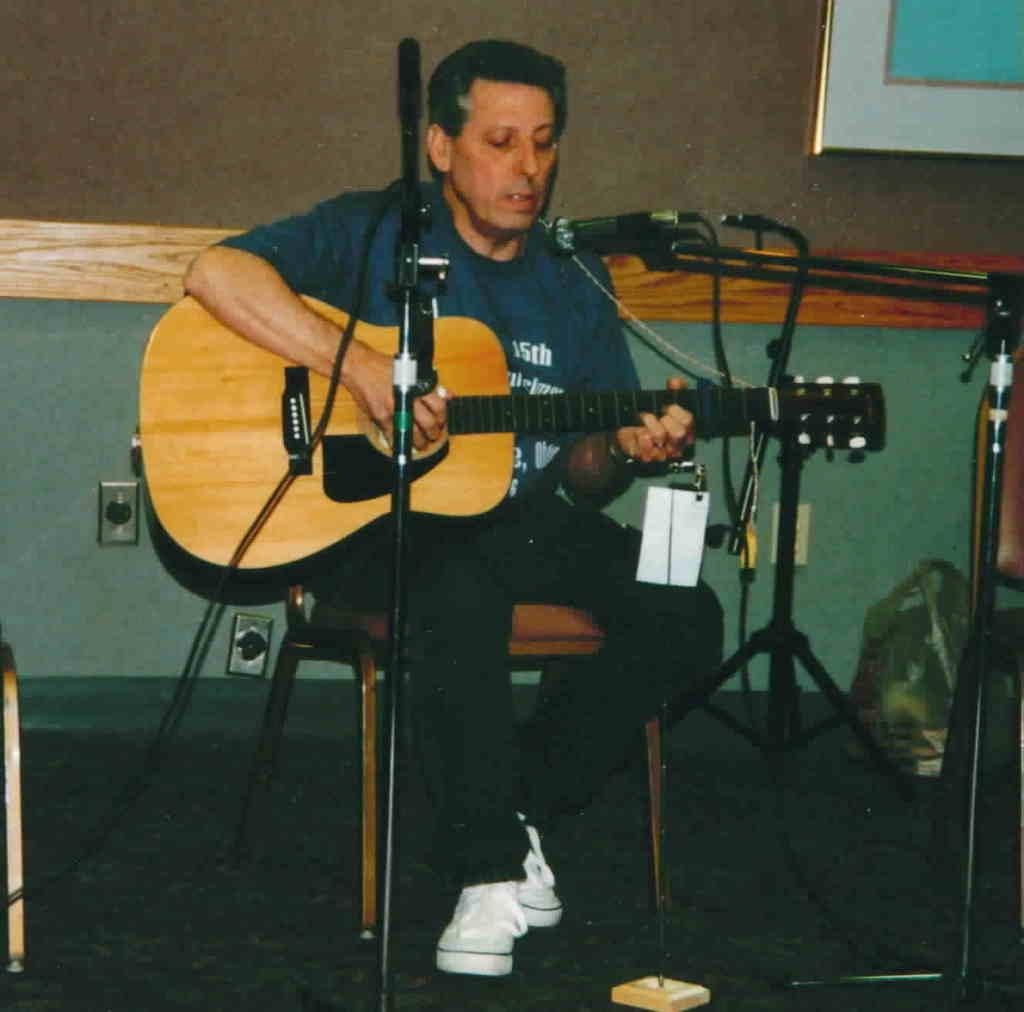Who is the main subject in the image? There is a man in the image. What is the man doing in the image? The man is sitting on a chair and holding a guitar. What object is in front of the man? There is a microphone in front of the man. What can be seen in the background of the image? There is a wall visible in the background. How many sacks can be seen in the image? There are no sacks present in the image. What type of station is visible in the background of the image? There is no station visible in the image; only a wall can be seen in the background. 